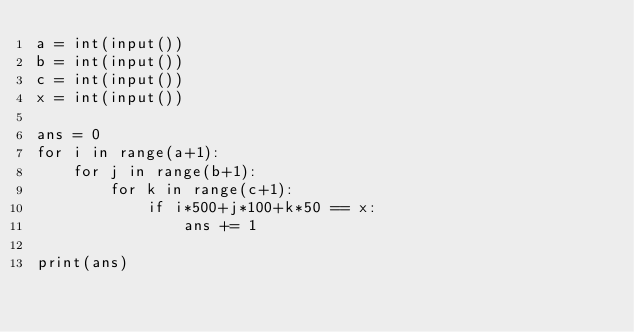Convert code to text. <code><loc_0><loc_0><loc_500><loc_500><_Python_>a = int(input())
b = int(input())
c = int(input())
x = int(input())

ans = 0
for i in range(a+1):
    for j in range(b+1):
        for k in range(c+1):
            if i*500+j*100+k*50 == x:
                ans += 1

print(ans)</code> 